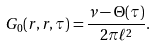<formula> <loc_0><loc_0><loc_500><loc_500>G _ { 0 } ( { r } , { r } , \tau ) = \frac { \nu - \Theta ( \tau ) } { 2 \pi \ell ^ { 2 } } .</formula> 